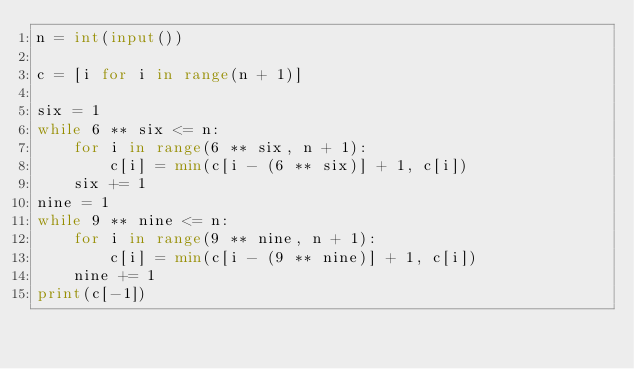Convert code to text. <code><loc_0><loc_0><loc_500><loc_500><_Python_>n = int(input())

c = [i for i in range(n + 1)]

six = 1
while 6 ** six <= n:
    for i in range(6 ** six, n + 1):
        c[i] = min(c[i - (6 ** six)] + 1, c[i])
    six += 1
nine = 1
while 9 ** nine <= n:
    for i in range(9 ** nine, n + 1):
        c[i] = min(c[i - (9 ** nine)] + 1, c[i])
    nine += 1
print(c[-1])</code> 